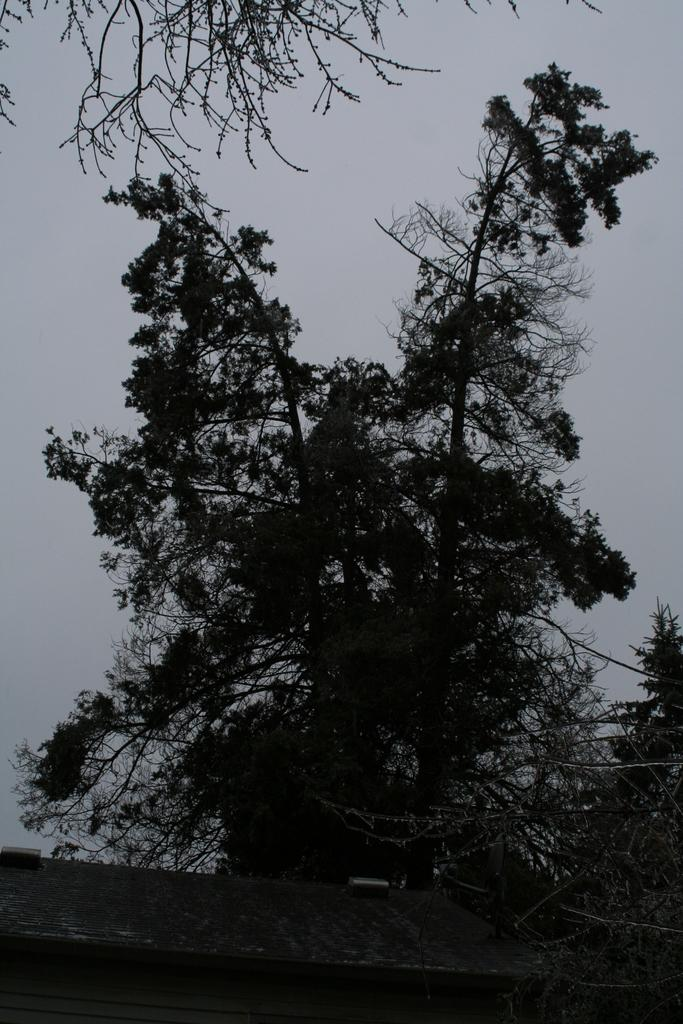What type of vegetation can be seen in the image? There are trees in the image. What structure is visible in the image? There is a wall in the image. What part of the natural environment is visible in the image? The sky is visible in the image. What is the condition of the sky in the image? The sky appears to be cloudy in the image. How many girls are present in the image? There are no girls present in the image. What type of hospital can be seen in the image? There is no hospital present in the image. 